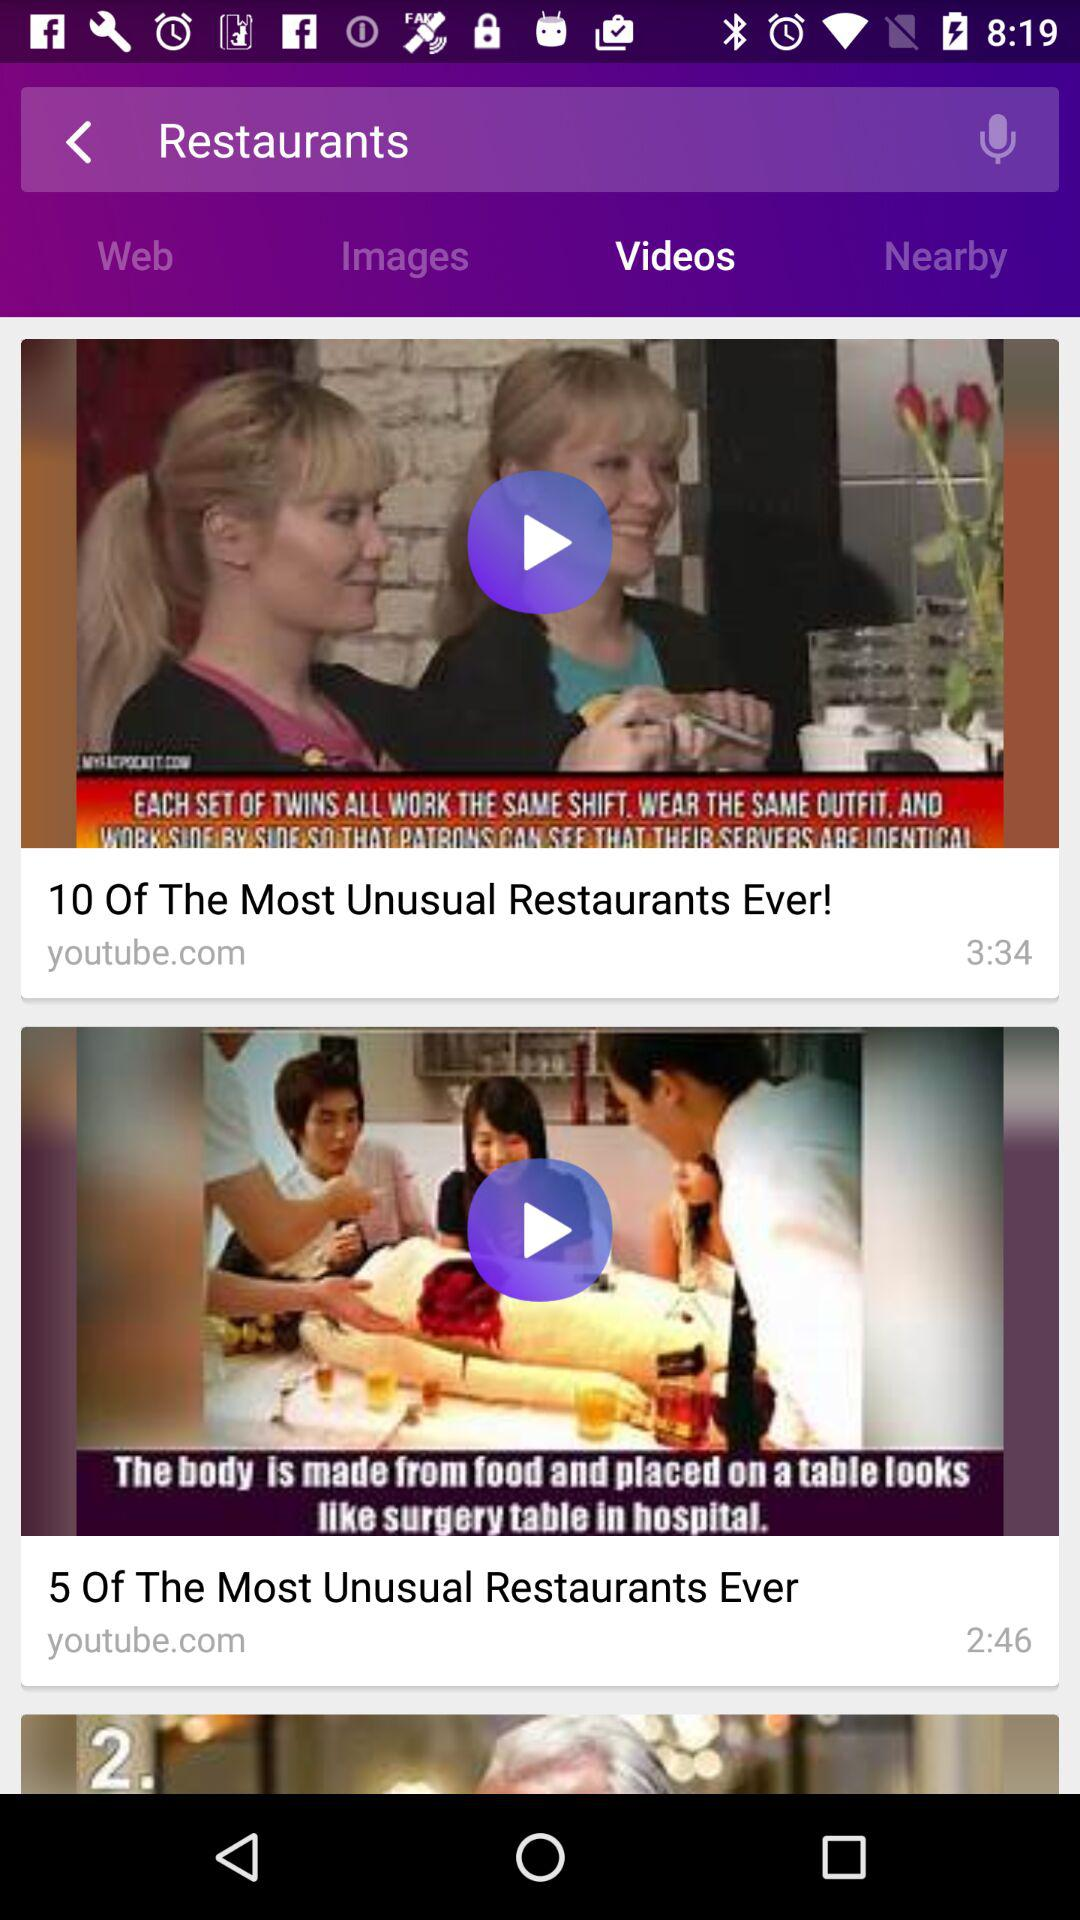Which tab is selected? The selected tab is "Videos". 